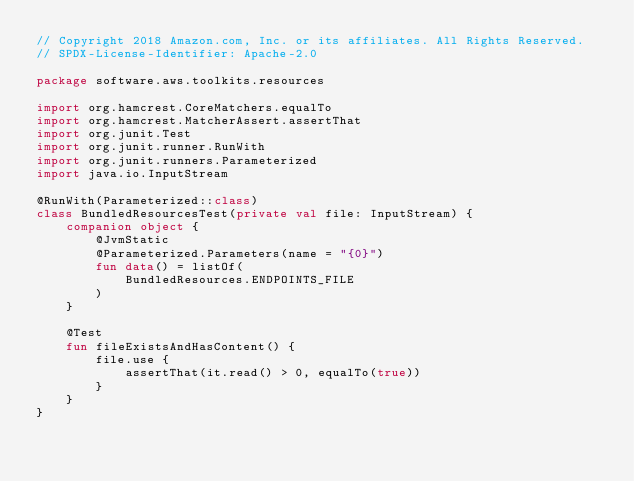<code> <loc_0><loc_0><loc_500><loc_500><_Kotlin_>// Copyright 2018 Amazon.com, Inc. or its affiliates. All Rights Reserved.
// SPDX-License-Identifier: Apache-2.0

package software.aws.toolkits.resources

import org.hamcrest.CoreMatchers.equalTo
import org.hamcrest.MatcherAssert.assertThat
import org.junit.Test
import org.junit.runner.RunWith
import org.junit.runners.Parameterized
import java.io.InputStream

@RunWith(Parameterized::class)
class BundledResourcesTest(private val file: InputStream) {
    companion object {
        @JvmStatic
        @Parameterized.Parameters(name = "{0}")
        fun data() = listOf(
            BundledResources.ENDPOINTS_FILE
        )
    }

    @Test
    fun fileExistsAndHasContent() {
        file.use {
            assertThat(it.read() > 0, equalTo(true))
        }
    }
}</code> 